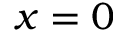<formula> <loc_0><loc_0><loc_500><loc_500>x = 0</formula> 